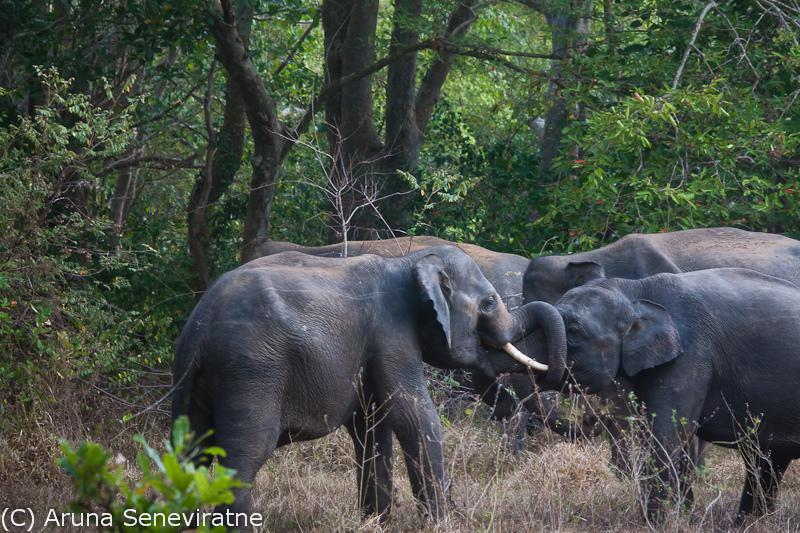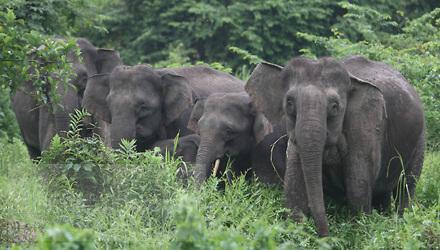The first image is the image on the left, the second image is the image on the right. Evaluate the accuracy of this statement regarding the images: "The right image shows an elephant with large tusks.". Is it true? Answer yes or no. No. 